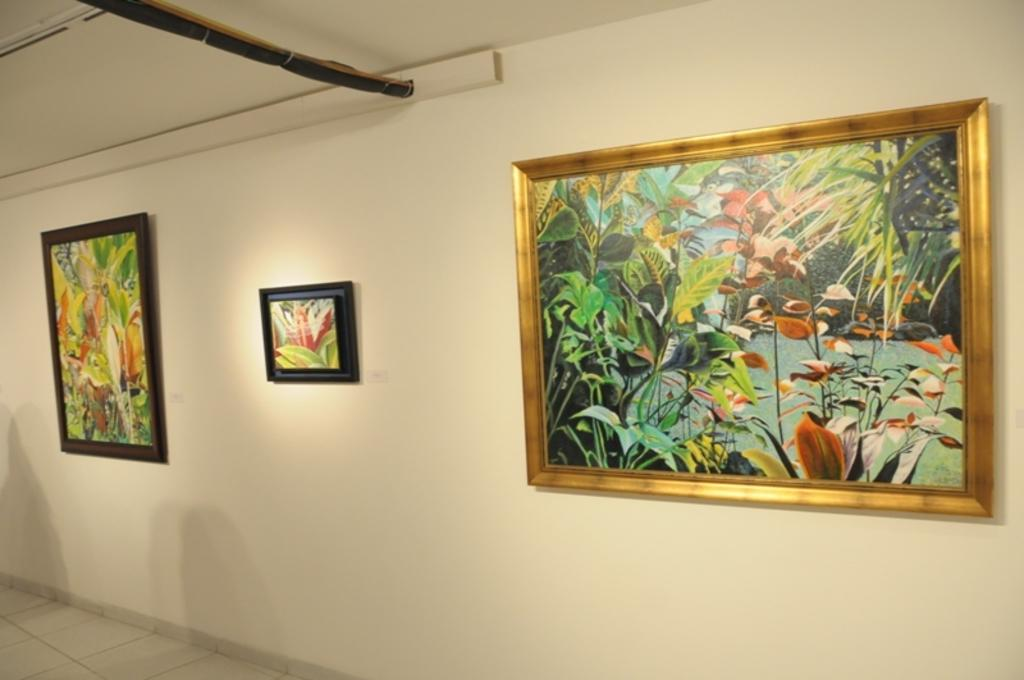What is hanging on the wall in the image? There are photo frames on a wall in the image. What part of a building can be seen in the image? There is a roof visible in the image. What surface is visible at the bottom of the image? There is a floor visible in the image. Can you see a branch being used in a battle in the image? There is no branch or battle present in the image. Is there a whip visible in the image? There is no whip present in the image. 